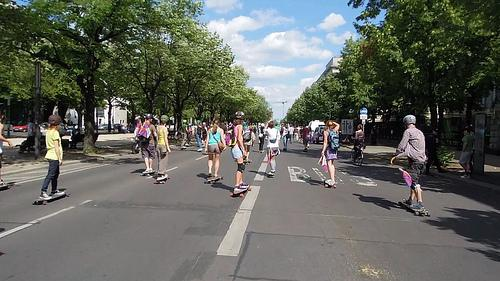Provide a brief overview of the scene depicted in the image. The image shows a group of skateboarders riding down a street, surrounded by trees and a clear blue sky. Give a description of the environment in which the image was taken. The picture is taken outside on a sunny day, with a blue sky and white clouds, and green trees lining the street. Point out the distinctive elements seen on the street in this image. The street has white lines and large words, and there's even a street sign visible in the picture. How would you depict the weather and sky in the image? The weather appears to be pleasant with the sun shining, and the sky is light blue with soft fluffy white clouds. Describe the vegetation seen in the picture. There are tall green trees with dark green leaves, brown trunks, and green leaves on the sides of the street. Mention a few important details about the woman wearing a helmet. A woman wearing a helmet and blue shorts is actively skateboarding in the group. What types of clothing can be observed amongst the skateboarders in the image? The skateboarders are wearing various clothes such as yellow shirt, blue shorts, green shirt, brown shorts, tight black pants, and helmets. Mention the primary activity taking place in the image. Several people are skateboarding down the center of a road. Describe the appearance and attire of a girl in the image. There's a girl in a yellow shirt and blue jeans riding a skateboard among the group. What types of safety gear are visible on the skateboarders in the image? Some of the skateboarders are wearing helmets and one even has black knee pads on for added protection. 